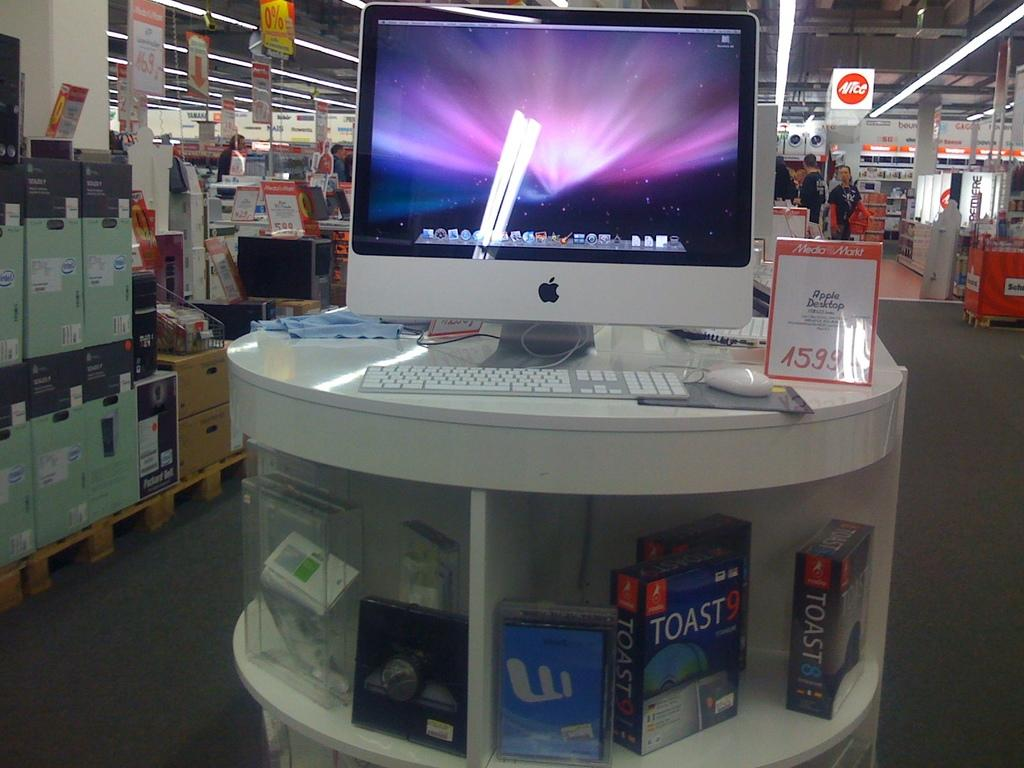<image>
Describe the image concisely. An Apple computer is on sale at a store for 1599. 